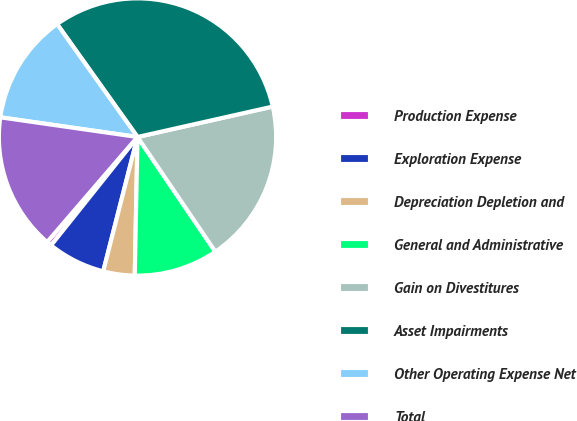Convert chart. <chart><loc_0><loc_0><loc_500><loc_500><pie_chart><fcel>Production Expense<fcel>Exploration Expense<fcel>Depreciation Depletion and<fcel>General and Administrative<fcel>Gain on Divestitures<fcel>Asset Impairments<fcel>Other Operating Expense Net<fcel>Total<nl><fcel>0.59%<fcel>6.74%<fcel>3.66%<fcel>9.81%<fcel>19.03%<fcel>31.33%<fcel>12.88%<fcel>15.96%<nl></chart> 